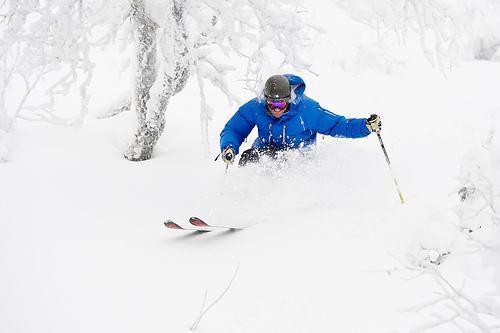How many men are there?
Give a very brief answer. 1. 